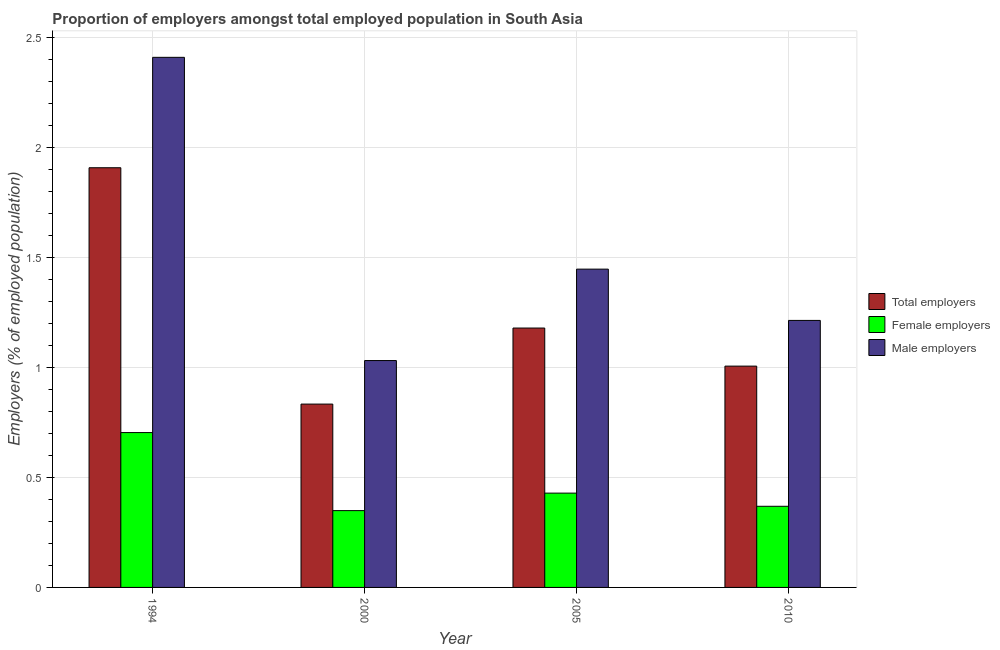How many groups of bars are there?
Your response must be concise. 4. Are the number of bars per tick equal to the number of legend labels?
Keep it short and to the point. Yes. Are the number of bars on each tick of the X-axis equal?
Provide a short and direct response. Yes. How many bars are there on the 2nd tick from the left?
Offer a very short reply. 3. How many bars are there on the 3rd tick from the right?
Your response must be concise. 3. What is the label of the 3rd group of bars from the left?
Give a very brief answer. 2005. In how many cases, is the number of bars for a given year not equal to the number of legend labels?
Keep it short and to the point. 0. What is the percentage of female employers in 2010?
Give a very brief answer. 0.37. Across all years, what is the maximum percentage of female employers?
Ensure brevity in your answer.  0.7. Across all years, what is the minimum percentage of male employers?
Ensure brevity in your answer.  1.03. What is the total percentage of male employers in the graph?
Give a very brief answer. 6.1. What is the difference between the percentage of female employers in 2000 and that in 2010?
Your response must be concise. -0.02. What is the difference between the percentage of total employers in 2005 and the percentage of female employers in 1994?
Your answer should be compact. -0.73. What is the average percentage of male employers per year?
Your response must be concise. 1.52. What is the ratio of the percentage of female employers in 2000 to that in 2010?
Provide a succinct answer. 0.95. Is the percentage of male employers in 2000 less than that in 2010?
Your answer should be very brief. Yes. Is the difference between the percentage of female employers in 2000 and 2010 greater than the difference between the percentage of total employers in 2000 and 2010?
Make the answer very short. No. What is the difference between the highest and the second highest percentage of male employers?
Offer a terse response. 0.96. What is the difference between the highest and the lowest percentage of female employers?
Make the answer very short. 0.35. In how many years, is the percentage of total employers greater than the average percentage of total employers taken over all years?
Your answer should be very brief. 1. Is the sum of the percentage of male employers in 1994 and 2005 greater than the maximum percentage of total employers across all years?
Your answer should be very brief. Yes. What does the 2nd bar from the left in 2005 represents?
Ensure brevity in your answer.  Female employers. What does the 2nd bar from the right in 2010 represents?
Make the answer very short. Female employers. Is it the case that in every year, the sum of the percentage of total employers and percentage of female employers is greater than the percentage of male employers?
Give a very brief answer. Yes. What is the difference between two consecutive major ticks on the Y-axis?
Offer a very short reply. 0.5. Does the graph contain any zero values?
Keep it short and to the point. No. Where does the legend appear in the graph?
Give a very brief answer. Center right. What is the title of the graph?
Ensure brevity in your answer.  Proportion of employers amongst total employed population in South Asia. Does "Ores and metals" appear as one of the legend labels in the graph?
Give a very brief answer. No. What is the label or title of the X-axis?
Provide a short and direct response. Year. What is the label or title of the Y-axis?
Give a very brief answer. Employers (% of employed population). What is the Employers (% of employed population) of Total employers in 1994?
Your response must be concise. 1.91. What is the Employers (% of employed population) in Female employers in 1994?
Your answer should be very brief. 0.7. What is the Employers (% of employed population) of Male employers in 1994?
Your answer should be compact. 2.41. What is the Employers (% of employed population) of Total employers in 2000?
Offer a very short reply. 0.83. What is the Employers (% of employed population) in Female employers in 2000?
Your answer should be compact. 0.35. What is the Employers (% of employed population) in Male employers in 2000?
Your answer should be compact. 1.03. What is the Employers (% of employed population) of Total employers in 2005?
Your answer should be very brief. 1.18. What is the Employers (% of employed population) of Female employers in 2005?
Ensure brevity in your answer.  0.43. What is the Employers (% of employed population) in Male employers in 2005?
Offer a terse response. 1.45. What is the Employers (% of employed population) in Total employers in 2010?
Ensure brevity in your answer.  1.01. What is the Employers (% of employed population) in Female employers in 2010?
Ensure brevity in your answer.  0.37. What is the Employers (% of employed population) of Male employers in 2010?
Give a very brief answer. 1.21. Across all years, what is the maximum Employers (% of employed population) in Total employers?
Keep it short and to the point. 1.91. Across all years, what is the maximum Employers (% of employed population) of Female employers?
Your answer should be very brief. 0.7. Across all years, what is the maximum Employers (% of employed population) of Male employers?
Offer a very short reply. 2.41. Across all years, what is the minimum Employers (% of employed population) in Total employers?
Offer a very short reply. 0.83. Across all years, what is the minimum Employers (% of employed population) of Female employers?
Your answer should be very brief. 0.35. Across all years, what is the minimum Employers (% of employed population) in Male employers?
Offer a very short reply. 1.03. What is the total Employers (% of employed population) in Total employers in the graph?
Give a very brief answer. 4.92. What is the total Employers (% of employed population) in Female employers in the graph?
Your answer should be very brief. 1.85. What is the total Employers (% of employed population) in Male employers in the graph?
Ensure brevity in your answer.  6.1. What is the difference between the Employers (% of employed population) of Total employers in 1994 and that in 2000?
Make the answer very short. 1.07. What is the difference between the Employers (% of employed population) in Female employers in 1994 and that in 2000?
Your response must be concise. 0.35. What is the difference between the Employers (% of employed population) in Male employers in 1994 and that in 2000?
Give a very brief answer. 1.38. What is the difference between the Employers (% of employed population) of Total employers in 1994 and that in 2005?
Provide a short and direct response. 0.73. What is the difference between the Employers (% of employed population) of Female employers in 1994 and that in 2005?
Provide a succinct answer. 0.28. What is the difference between the Employers (% of employed population) in Male employers in 1994 and that in 2005?
Your response must be concise. 0.96. What is the difference between the Employers (% of employed population) of Total employers in 1994 and that in 2010?
Your response must be concise. 0.9. What is the difference between the Employers (% of employed population) of Female employers in 1994 and that in 2010?
Make the answer very short. 0.33. What is the difference between the Employers (% of employed population) in Male employers in 1994 and that in 2010?
Give a very brief answer. 1.2. What is the difference between the Employers (% of employed population) in Total employers in 2000 and that in 2005?
Your answer should be compact. -0.35. What is the difference between the Employers (% of employed population) in Female employers in 2000 and that in 2005?
Provide a succinct answer. -0.08. What is the difference between the Employers (% of employed population) of Male employers in 2000 and that in 2005?
Give a very brief answer. -0.42. What is the difference between the Employers (% of employed population) of Total employers in 2000 and that in 2010?
Provide a short and direct response. -0.17. What is the difference between the Employers (% of employed population) in Female employers in 2000 and that in 2010?
Offer a terse response. -0.02. What is the difference between the Employers (% of employed population) of Male employers in 2000 and that in 2010?
Ensure brevity in your answer.  -0.18. What is the difference between the Employers (% of employed population) in Total employers in 2005 and that in 2010?
Give a very brief answer. 0.17. What is the difference between the Employers (% of employed population) in Female employers in 2005 and that in 2010?
Make the answer very short. 0.06. What is the difference between the Employers (% of employed population) in Male employers in 2005 and that in 2010?
Provide a short and direct response. 0.23. What is the difference between the Employers (% of employed population) in Total employers in 1994 and the Employers (% of employed population) in Female employers in 2000?
Offer a very short reply. 1.56. What is the difference between the Employers (% of employed population) of Total employers in 1994 and the Employers (% of employed population) of Male employers in 2000?
Offer a terse response. 0.88. What is the difference between the Employers (% of employed population) in Female employers in 1994 and the Employers (% of employed population) in Male employers in 2000?
Make the answer very short. -0.33. What is the difference between the Employers (% of employed population) in Total employers in 1994 and the Employers (% of employed population) in Female employers in 2005?
Offer a terse response. 1.48. What is the difference between the Employers (% of employed population) of Total employers in 1994 and the Employers (% of employed population) of Male employers in 2005?
Ensure brevity in your answer.  0.46. What is the difference between the Employers (% of employed population) of Female employers in 1994 and the Employers (% of employed population) of Male employers in 2005?
Provide a short and direct response. -0.74. What is the difference between the Employers (% of employed population) of Total employers in 1994 and the Employers (% of employed population) of Female employers in 2010?
Give a very brief answer. 1.54. What is the difference between the Employers (% of employed population) in Total employers in 1994 and the Employers (% of employed population) in Male employers in 2010?
Your answer should be very brief. 0.69. What is the difference between the Employers (% of employed population) of Female employers in 1994 and the Employers (% of employed population) of Male employers in 2010?
Your answer should be compact. -0.51. What is the difference between the Employers (% of employed population) of Total employers in 2000 and the Employers (% of employed population) of Female employers in 2005?
Your response must be concise. 0.4. What is the difference between the Employers (% of employed population) of Total employers in 2000 and the Employers (% of employed population) of Male employers in 2005?
Your answer should be compact. -0.61. What is the difference between the Employers (% of employed population) of Female employers in 2000 and the Employers (% of employed population) of Male employers in 2005?
Keep it short and to the point. -1.1. What is the difference between the Employers (% of employed population) of Total employers in 2000 and the Employers (% of employed population) of Female employers in 2010?
Keep it short and to the point. 0.46. What is the difference between the Employers (% of employed population) of Total employers in 2000 and the Employers (% of employed population) of Male employers in 2010?
Ensure brevity in your answer.  -0.38. What is the difference between the Employers (% of employed population) in Female employers in 2000 and the Employers (% of employed population) in Male employers in 2010?
Ensure brevity in your answer.  -0.86. What is the difference between the Employers (% of employed population) of Total employers in 2005 and the Employers (% of employed population) of Female employers in 2010?
Provide a short and direct response. 0.81. What is the difference between the Employers (% of employed population) of Total employers in 2005 and the Employers (% of employed population) of Male employers in 2010?
Offer a terse response. -0.03. What is the difference between the Employers (% of employed population) of Female employers in 2005 and the Employers (% of employed population) of Male employers in 2010?
Offer a terse response. -0.78. What is the average Employers (% of employed population) in Total employers per year?
Make the answer very short. 1.23. What is the average Employers (% of employed population) in Female employers per year?
Offer a terse response. 0.46. What is the average Employers (% of employed population) in Male employers per year?
Provide a short and direct response. 1.52. In the year 1994, what is the difference between the Employers (% of employed population) of Total employers and Employers (% of employed population) of Female employers?
Ensure brevity in your answer.  1.2. In the year 1994, what is the difference between the Employers (% of employed population) in Total employers and Employers (% of employed population) in Male employers?
Keep it short and to the point. -0.5. In the year 1994, what is the difference between the Employers (% of employed population) of Female employers and Employers (% of employed population) of Male employers?
Give a very brief answer. -1.71. In the year 2000, what is the difference between the Employers (% of employed population) in Total employers and Employers (% of employed population) in Female employers?
Offer a very short reply. 0.48. In the year 2000, what is the difference between the Employers (% of employed population) in Total employers and Employers (% of employed population) in Male employers?
Ensure brevity in your answer.  -0.2. In the year 2000, what is the difference between the Employers (% of employed population) in Female employers and Employers (% of employed population) in Male employers?
Ensure brevity in your answer.  -0.68. In the year 2005, what is the difference between the Employers (% of employed population) in Total employers and Employers (% of employed population) in Female employers?
Your answer should be compact. 0.75. In the year 2005, what is the difference between the Employers (% of employed population) in Total employers and Employers (% of employed population) in Male employers?
Give a very brief answer. -0.27. In the year 2005, what is the difference between the Employers (% of employed population) of Female employers and Employers (% of employed population) of Male employers?
Your response must be concise. -1.02. In the year 2010, what is the difference between the Employers (% of employed population) of Total employers and Employers (% of employed population) of Female employers?
Offer a very short reply. 0.64. In the year 2010, what is the difference between the Employers (% of employed population) in Total employers and Employers (% of employed population) in Male employers?
Your answer should be compact. -0.21. In the year 2010, what is the difference between the Employers (% of employed population) of Female employers and Employers (% of employed population) of Male employers?
Your answer should be compact. -0.84. What is the ratio of the Employers (% of employed population) of Total employers in 1994 to that in 2000?
Provide a short and direct response. 2.29. What is the ratio of the Employers (% of employed population) in Female employers in 1994 to that in 2000?
Provide a short and direct response. 2.02. What is the ratio of the Employers (% of employed population) of Male employers in 1994 to that in 2000?
Your answer should be compact. 2.34. What is the ratio of the Employers (% of employed population) in Total employers in 1994 to that in 2005?
Your response must be concise. 1.62. What is the ratio of the Employers (% of employed population) of Female employers in 1994 to that in 2005?
Your response must be concise. 1.64. What is the ratio of the Employers (% of employed population) in Male employers in 1994 to that in 2005?
Provide a succinct answer. 1.67. What is the ratio of the Employers (% of employed population) in Total employers in 1994 to that in 2010?
Keep it short and to the point. 1.9. What is the ratio of the Employers (% of employed population) in Female employers in 1994 to that in 2010?
Make the answer very short. 1.91. What is the ratio of the Employers (% of employed population) of Male employers in 1994 to that in 2010?
Make the answer very short. 1.99. What is the ratio of the Employers (% of employed population) in Total employers in 2000 to that in 2005?
Offer a very short reply. 0.71. What is the ratio of the Employers (% of employed population) in Female employers in 2000 to that in 2005?
Your response must be concise. 0.81. What is the ratio of the Employers (% of employed population) of Male employers in 2000 to that in 2005?
Your response must be concise. 0.71. What is the ratio of the Employers (% of employed population) in Total employers in 2000 to that in 2010?
Your answer should be very brief. 0.83. What is the ratio of the Employers (% of employed population) in Female employers in 2000 to that in 2010?
Make the answer very short. 0.95. What is the ratio of the Employers (% of employed population) in Male employers in 2000 to that in 2010?
Your response must be concise. 0.85. What is the ratio of the Employers (% of employed population) of Total employers in 2005 to that in 2010?
Give a very brief answer. 1.17. What is the ratio of the Employers (% of employed population) of Female employers in 2005 to that in 2010?
Your answer should be very brief. 1.16. What is the ratio of the Employers (% of employed population) in Male employers in 2005 to that in 2010?
Provide a short and direct response. 1.19. What is the difference between the highest and the second highest Employers (% of employed population) in Total employers?
Provide a short and direct response. 0.73. What is the difference between the highest and the second highest Employers (% of employed population) in Female employers?
Make the answer very short. 0.28. What is the difference between the highest and the second highest Employers (% of employed population) in Male employers?
Ensure brevity in your answer.  0.96. What is the difference between the highest and the lowest Employers (% of employed population) of Total employers?
Make the answer very short. 1.07. What is the difference between the highest and the lowest Employers (% of employed population) in Female employers?
Offer a terse response. 0.35. What is the difference between the highest and the lowest Employers (% of employed population) in Male employers?
Offer a very short reply. 1.38. 